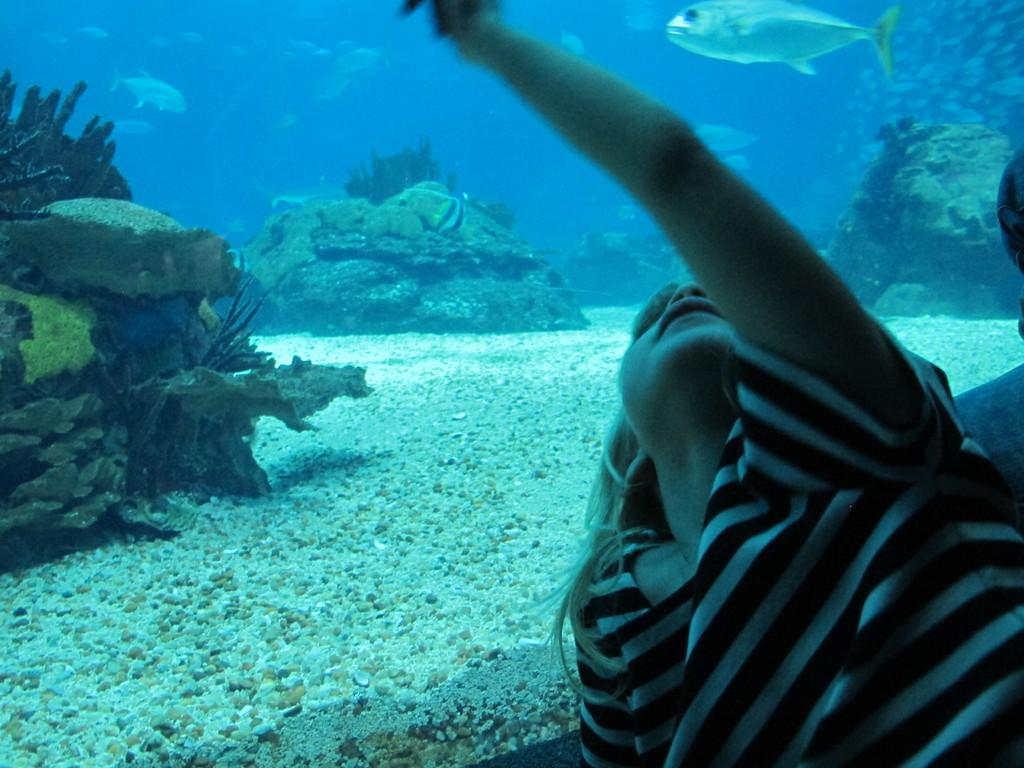Who is present in the image? There is a girl in the image. Where is the girl located in the image? The girl is at the bottom of the image. What can be seen in the background of the image? There is water visible in the image. What is in the water? There is a fish and stones visible in the water. What is the tendency of the line in the image? There is no line present in the image. 